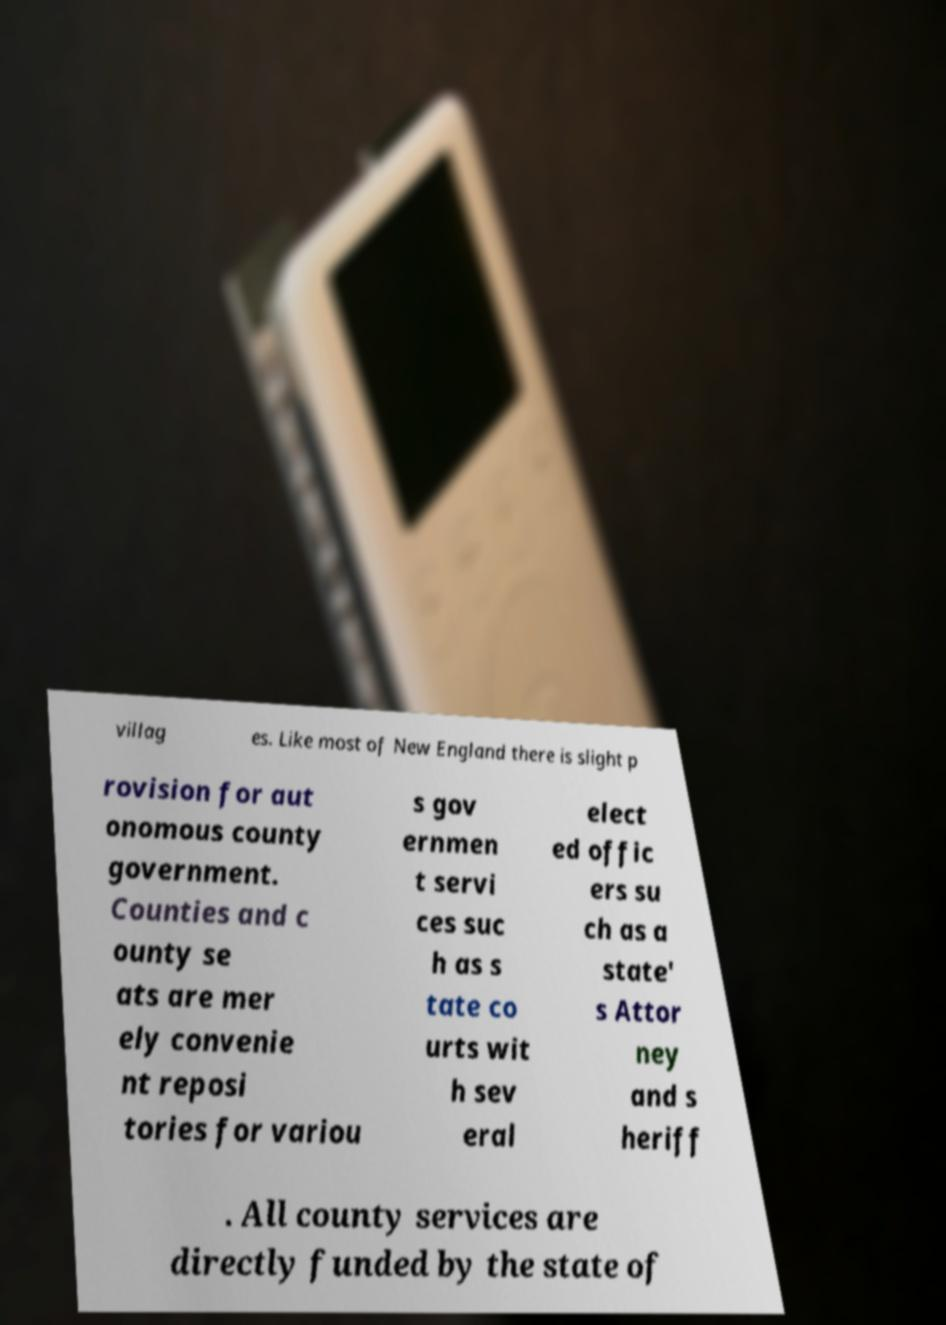For documentation purposes, I need the text within this image transcribed. Could you provide that? villag es. Like most of New England there is slight p rovision for aut onomous county government. Counties and c ounty se ats are mer ely convenie nt reposi tories for variou s gov ernmen t servi ces suc h as s tate co urts wit h sev eral elect ed offic ers su ch as a state' s Attor ney and s heriff . All county services are directly funded by the state of 